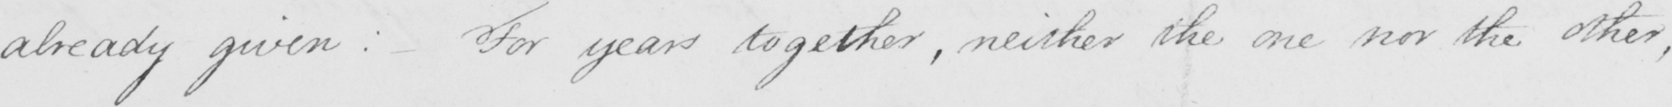Can you read and transcribe this handwriting? already given :  For years together , neither the one nor the other , 